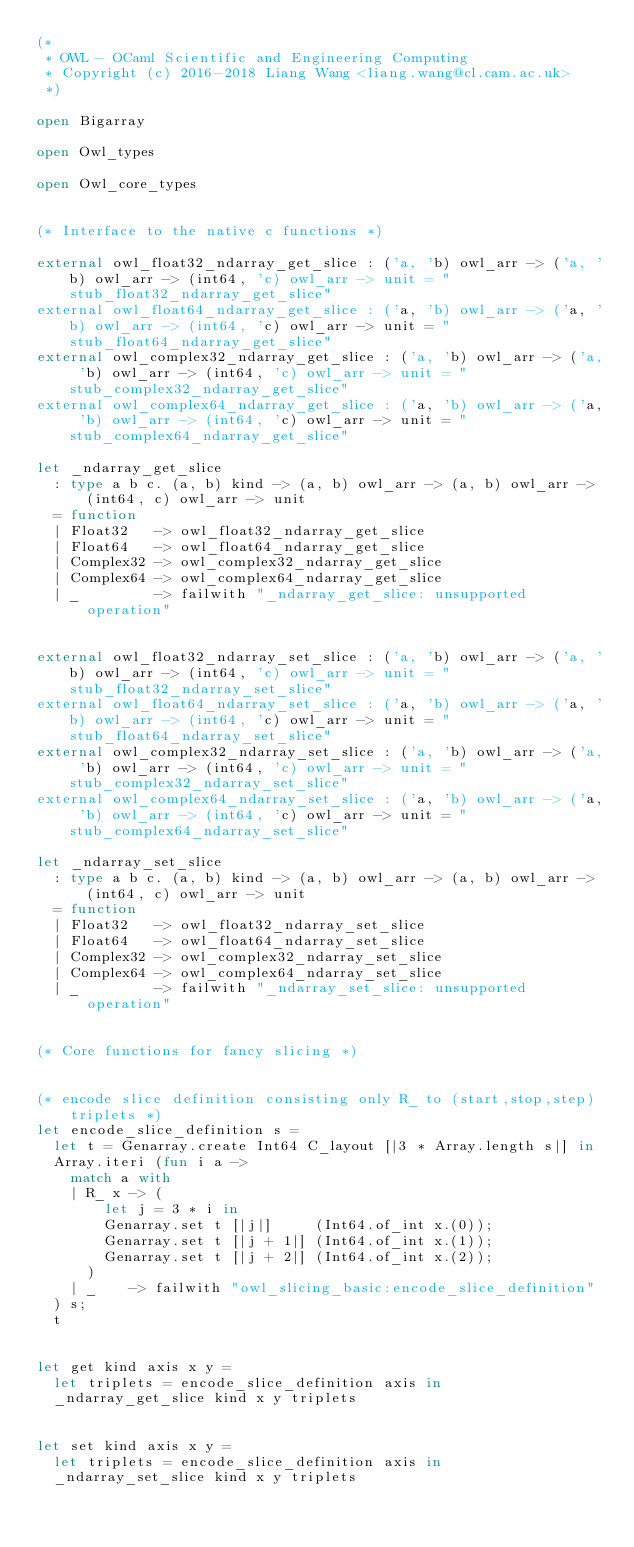Convert code to text. <code><loc_0><loc_0><loc_500><loc_500><_OCaml_>(*
 * OWL - OCaml Scientific and Engineering Computing
 * Copyright (c) 2016-2018 Liang Wang <liang.wang@cl.cam.ac.uk>
 *)

open Bigarray

open Owl_types

open Owl_core_types


(* Interface to the native c functions *)

external owl_float32_ndarray_get_slice : ('a, 'b) owl_arr -> ('a, 'b) owl_arr -> (int64, 'c) owl_arr -> unit = "stub_float32_ndarray_get_slice"
external owl_float64_ndarray_get_slice : ('a, 'b) owl_arr -> ('a, 'b) owl_arr -> (int64, 'c) owl_arr -> unit = "stub_float64_ndarray_get_slice"
external owl_complex32_ndarray_get_slice : ('a, 'b) owl_arr -> ('a, 'b) owl_arr -> (int64, 'c) owl_arr -> unit = "stub_complex32_ndarray_get_slice"
external owl_complex64_ndarray_get_slice : ('a, 'b) owl_arr -> ('a, 'b) owl_arr -> (int64, 'c) owl_arr -> unit = "stub_complex64_ndarray_get_slice"

let _ndarray_get_slice
  : type a b c. (a, b) kind -> (a, b) owl_arr -> (a, b) owl_arr -> (int64, c) owl_arr -> unit
  = function
  | Float32   -> owl_float32_ndarray_get_slice
  | Float64   -> owl_float64_ndarray_get_slice
  | Complex32 -> owl_complex32_ndarray_get_slice
  | Complex64 -> owl_complex64_ndarray_get_slice
  | _         -> failwith "_ndarray_get_slice: unsupported operation"


external owl_float32_ndarray_set_slice : ('a, 'b) owl_arr -> ('a, 'b) owl_arr -> (int64, 'c) owl_arr -> unit = "stub_float32_ndarray_set_slice"
external owl_float64_ndarray_set_slice : ('a, 'b) owl_arr -> ('a, 'b) owl_arr -> (int64, 'c) owl_arr -> unit = "stub_float64_ndarray_set_slice"
external owl_complex32_ndarray_set_slice : ('a, 'b) owl_arr -> ('a, 'b) owl_arr -> (int64, 'c) owl_arr -> unit = "stub_complex32_ndarray_set_slice"
external owl_complex64_ndarray_set_slice : ('a, 'b) owl_arr -> ('a, 'b) owl_arr -> (int64, 'c) owl_arr -> unit = "stub_complex64_ndarray_set_slice"

let _ndarray_set_slice
  : type a b c. (a, b) kind -> (a, b) owl_arr -> (a, b) owl_arr -> (int64, c) owl_arr -> unit
  = function
  | Float32   -> owl_float32_ndarray_set_slice
  | Float64   -> owl_float64_ndarray_set_slice
  | Complex32 -> owl_complex32_ndarray_set_slice
  | Complex64 -> owl_complex64_ndarray_set_slice
  | _         -> failwith "_ndarray_set_slice: unsupported operation"


(* Core functions for fancy slicing *)


(* encode slice definition consisting only R_ to (start,stop,step) triplets *)
let encode_slice_definition s =
  let t = Genarray.create Int64 C_layout [|3 * Array.length s|] in
  Array.iteri (fun i a ->
    match a with
    | R_ x -> (
        let j = 3 * i in
        Genarray.set t [|j|]     (Int64.of_int x.(0));
        Genarray.set t [|j + 1|] (Int64.of_int x.(1));
        Genarray.set t [|j + 2|] (Int64.of_int x.(2));
      )
    | _    -> failwith "owl_slicing_basic:encode_slice_definition"
  ) s;
  t


let get kind axis x y =
  let triplets = encode_slice_definition axis in
  _ndarray_get_slice kind x y triplets


let set kind axis x y =
  let triplets = encode_slice_definition axis in
  _ndarray_set_slice kind x y triplets
</code> 